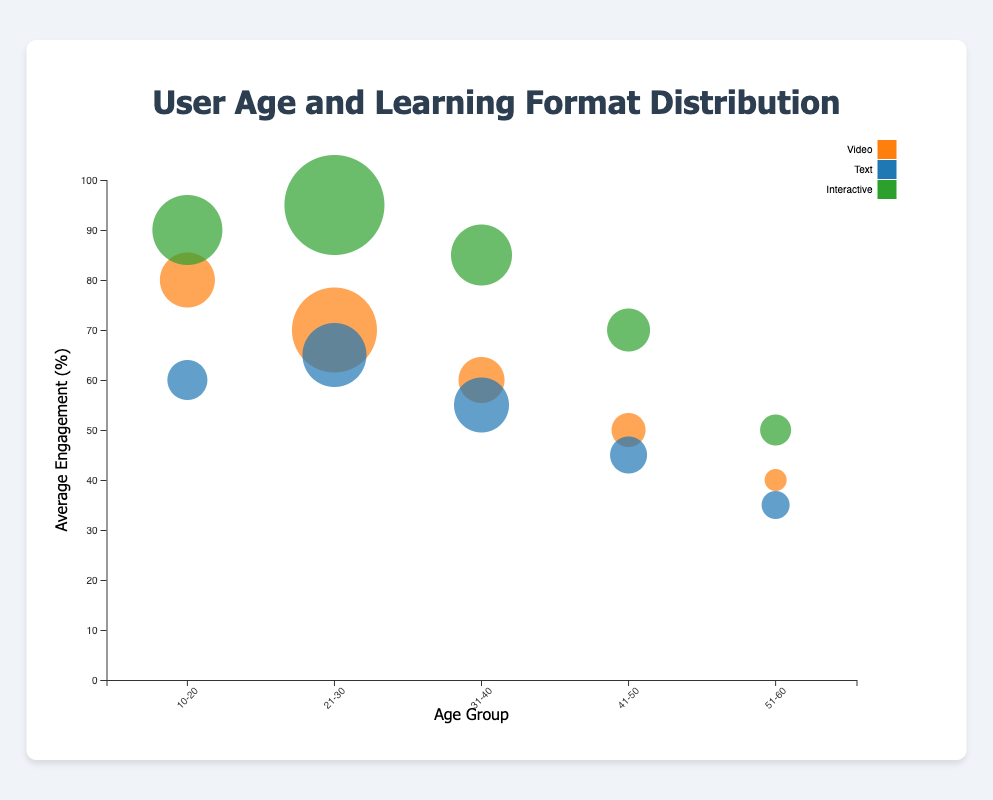What are the age groups shown in the figure? The x-axis of the bubble chart displays the different age groups as labels. By reading these labels, we can identify the distinct age groups present in the chart.
Answer: 10-20, 21-30, 31-40, 41-50, 51-60 How is the average engagement represented in the figure? The average engagement is represented on the y-axis of the bubble chart, where higher values indicate higher engagement. The vertical position of each bubble corresponds to its average engagement level.
Answer: By the vertical position of bubbles Which color represents the Interactive learning format? The legend on the right side of the figure uses colors to represent different learning formats. By referring to the legend, we can see that the color representing the Interactive learning format is green.
Answer: Green How many learning formats are shown in the figure? By examining the legend, we can identify the distinct learning formats presented in the figure along with their respective colors.
Answer: Three What is the average engagement for users aged 31-40 who prefer Video? To find the average engagement, locate the bubble representing the 31-40 age group and Video format, then read its vertical position corresponding to the y-axis. The average engagement for this group is 60%.
Answer: 60% Which age group has the largest bubble when considering the Interactive learning format? The size of the bubbles indicates the user count. Locate the age group with the largest bubble among those colored for the Interactive format, which is green. The age group 21-30 has the largest green bubble.
Answer: 21-30 Compare the user count for Text learning format between age groups 10-20 and 41-50. Which group has more users? Locate the bubbles for the Text format (blue) in each age group and compare their sizes. The bubble for the 10-20 age group is larger than that for the 41-50 age group, indicating more users.
Answer: 10-20 What is the total user count for the Video learning format across all age groups? Sum the user counts represented by the Video bubbles (orange) for all age groups: 150 (10-20) + 250 (21-30) + 120 (31-40) + 80 (41-50) + 40 (51-60) = 640.
Answer: 640 Which age group shows the highest average engagement, and in which format? To find the highest average engagement, look for the highest vertical position among all bubbles. The 21-30 age group with the Interactive format (green) has the highest bubble position, indicating 95% engagement.
Answer: 21-30, Interactive Is there an age group where the average engagement decreases as user count increases for any learning format? Compare both axes to find any learning format in an age group showing decreasing vertical bubbles with increasing bubble size. The trend can be spotted by examining vertical positions (engagement) against bubble sizes (users). No such decreases are found in this dataset.
Answer: No 